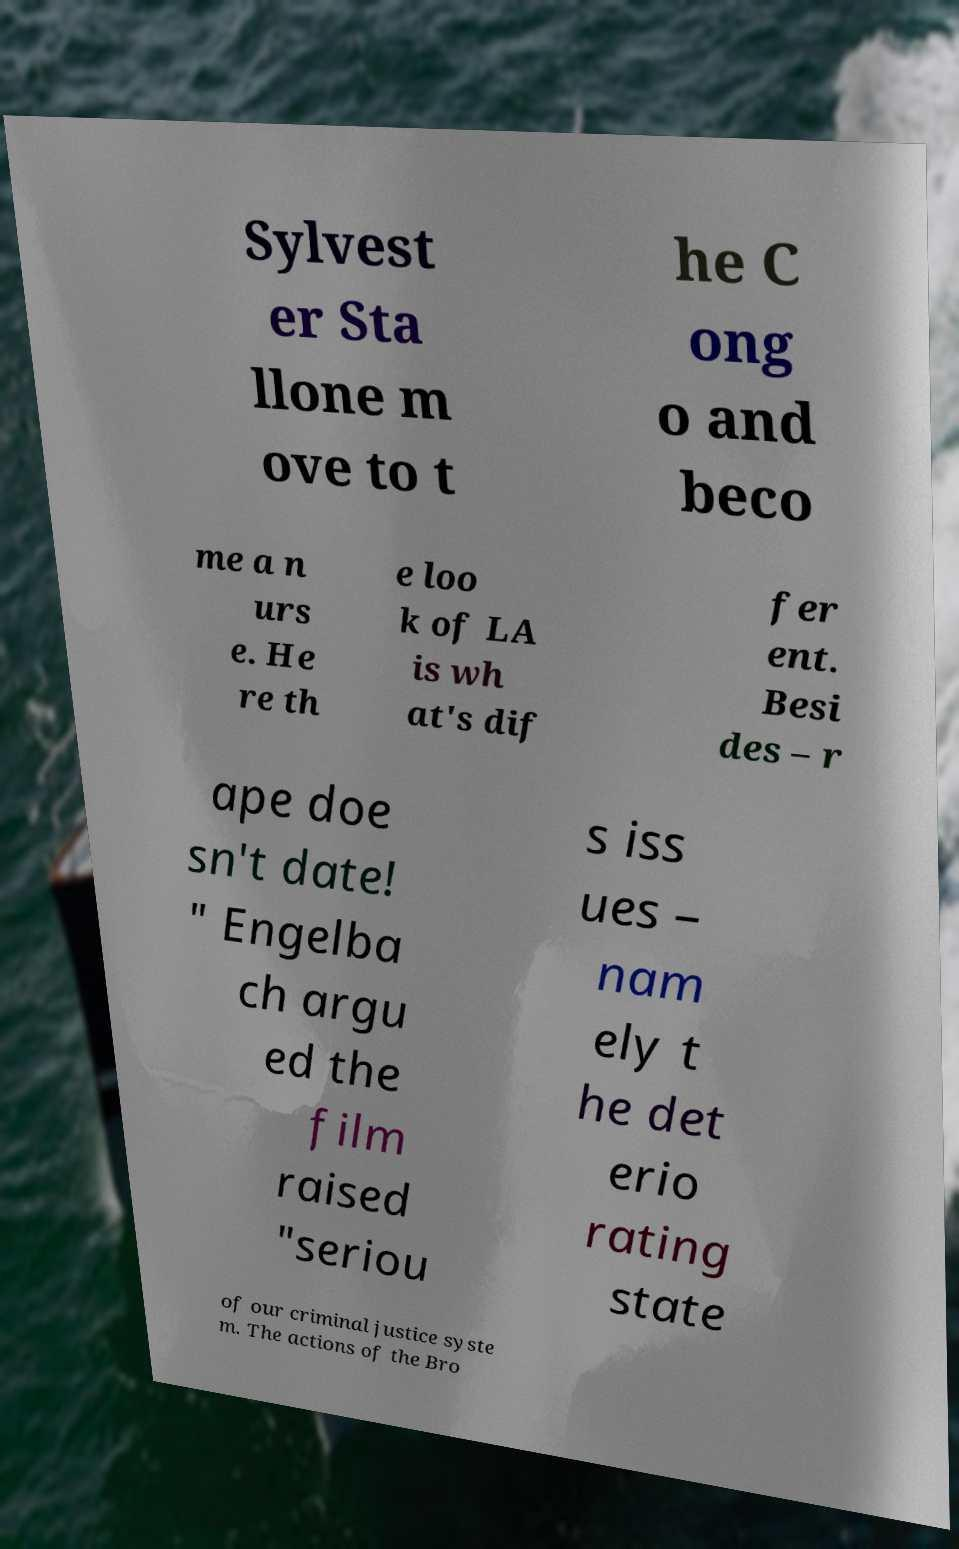There's text embedded in this image that I need extracted. Can you transcribe it verbatim? Sylvest er Sta llone m ove to t he C ong o and beco me a n urs e. He re th e loo k of LA is wh at's dif fer ent. Besi des – r ape doe sn't date! " Engelba ch argu ed the film raised "seriou s iss ues – nam ely t he det erio rating state of our criminal justice syste m. The actions of the Bro 